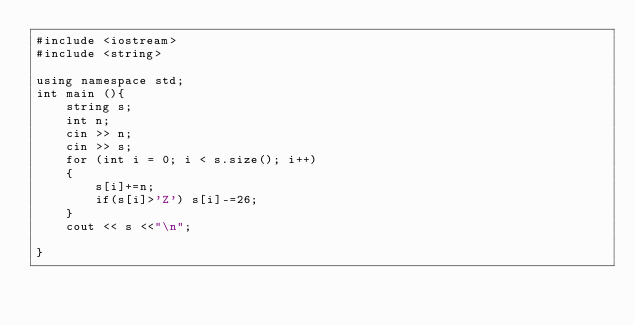Convert code to text. <code><loc_0><loc_0><loc_500><loc_500><_C++_>#include <iostream>
#include <string>

using namespace std;
int main (){
    string s;
    int n;
    cin >> n;
    cin >> s;
    for (int i = 0; i < s.size(); i++)
    {
        s[i]+=n;
        if(s[i]>'Z') s[i]-=26;
    }
    cout << s <<"\n";

}</code> 